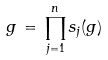<formula> <loc_0><loc_0><loc_500><loc_500>g \, = \, \prod _ { j = 1 } ^ { n } s _ { j } ( g )</formula> 